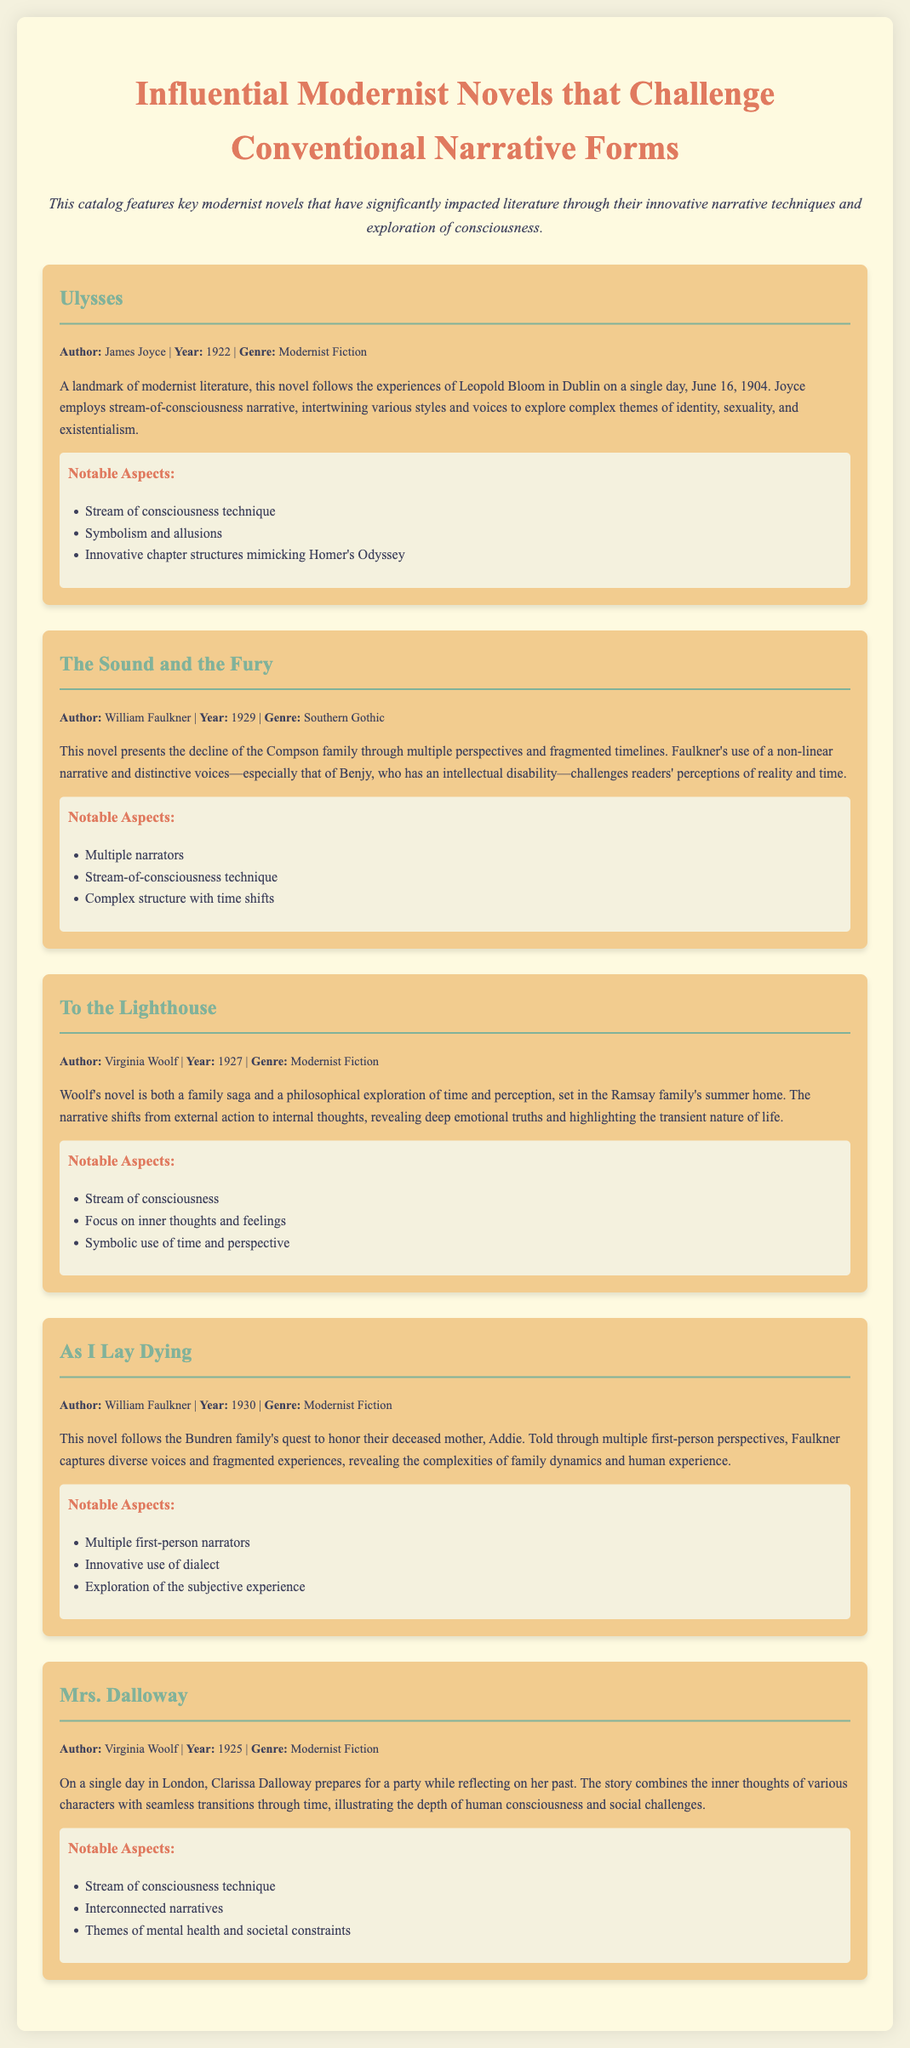What is the title of the novel by James Joyce? The title is mentioned in the catalog as "Ulysses."
Answer: Ulysses Who is the author of "To the Lighthouse"? The catalog states that Virginia Woolf is the author of this novel.
Answer: Virginia Woolf In what year was "The Sound and the Fury" published? The document provides the publication year as 1929.
Answer: 1929 What narrative technique is predominantly used in "Mrs. Dalloway"? The document highlights the use of the stream of consciousness technique in this novel.
Answer: Stream of consciousness How many first-person perspectives are presented in "As I Lay Dying"? The summary notes that the story is told through multiple first-person perspectives, emphasizing its fragmented nature.
Answer: Multiple Which novel explores themes of identity, sexuality, and existentialism? The summary of "Ulysses" indicates that these themes are central to the narrative.
Answer: Ulysses What genre is "The Sound and the Fury"? The catalog categorizes it as Southern Gothic.
Answer: Southern Gothic Which author wrote two novels featured in this catalog? Virginia Woolf is mentioned as the author of both "To the Lighthouse" and "Mrs. Dalloway."
Answer: Virginia Woolf What is a notable aspect of "The Sound and the Fury"? The document lists multiple narrators as one of its significant features.
Answer: Multiple narrators 